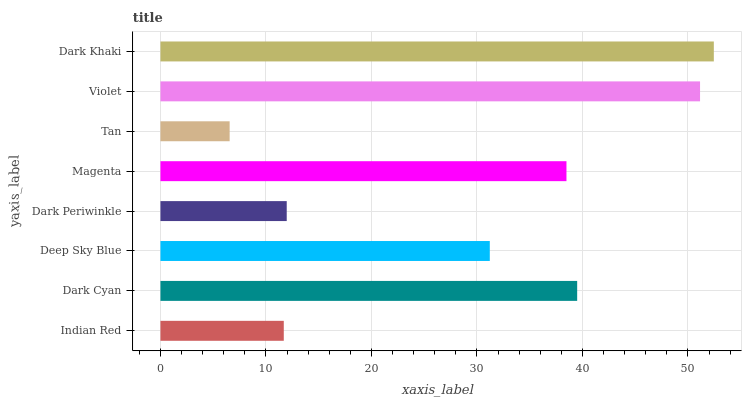Is Tan the minimum?
Answer yes or no. Yes. Is Dark Khaki the maximum?
Answer yes or no. Yes. Is Dark Cyan the minimum?
Answer yes or no. No. Is Dark Cyan the maximum?
Answer yes or no. No. Is Dark Cyan greater than Indian Red?
Answer yes or no. Yes. Is Indian Red less than Dark Cyan?
Answer yes or no. Yes. Is Indian Red greater than Dark Cyan?
Answer yes or no. No. Is Dark Cyan less than Indian Red?
Answer yes or no. No. Is Magenta the high median?
Answer yes or no. Yes. Is Deep Sky Blue the low median?
Answer yes or no. Yes. Is Tan the high median?
Answer yes or no. No. Is Indian Red the low median?
Answer yes or no. No. 